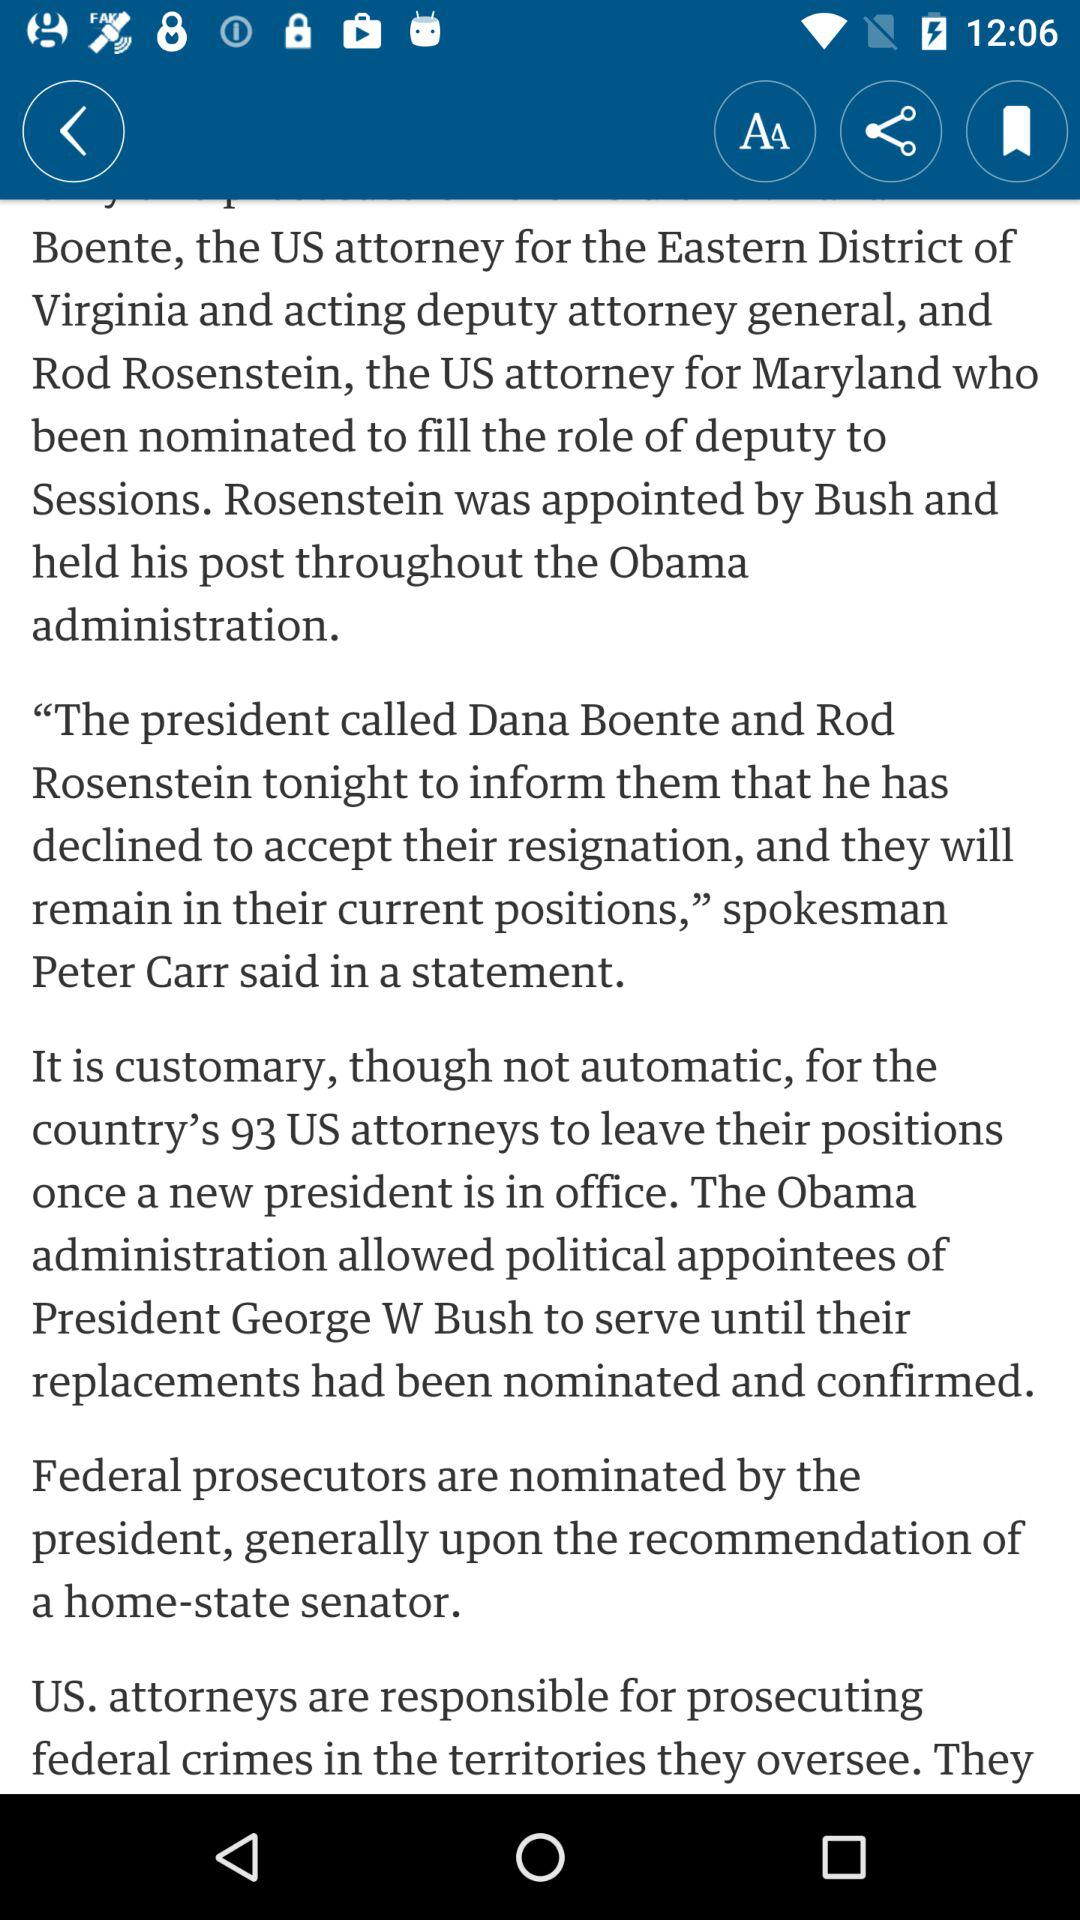By whom was Rod Rosenstein appointed? Rod Rosenstein was appointed by Bush. 